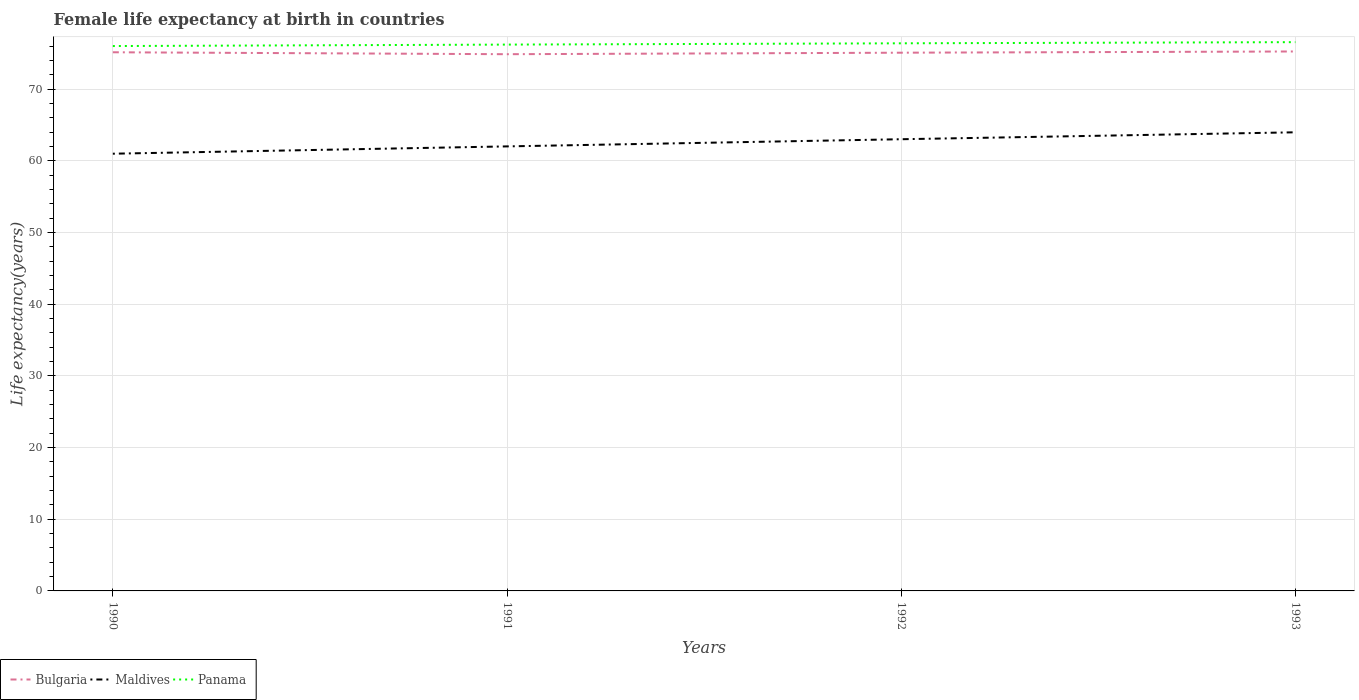Does the line corresponding to Bulgaria intersect with the line corresponding to Panama?
Offer a very short reply. No. Across all years, what is the maximum female life expectancy at birth in Maldives?
Keep it short and to the point. 61. What is the total female life expectancy at birth in Maldives in the graph?
Your answer should be very brief. -0.97. What is the difference between the highest and the second highest female life expectancy at birth in Panama?
Make the answer very short. 0.54. What is the difference between the highest and the lowest female life expectancy at birth in Maldives?
Your response must be concise. 2. How many years are there in the graph?
Give a very brief answer. 4. Are the values on the major ticks of Y-axis written in scientific E-notation?
Provide a short and direct response. No. Does the graph contain any zero values?
Your response must be concise. No. How are the legend labels stacked?
Your answer should be very brief. Horizontal. What is the title of the graph?
Offer a terse response. Female life expectancy at birth in countries. Does "Liberia" appear as one of the legend labels in the graph?
Ensure brevity in your answer.  No. What is the label or title of the Y-axis?
Your answer should be very brief. Life expectancy(years). What is the Life expectancy(years) of Bulgaria in 1990?
Your response must be concise. 75.15. What is the Life expectancy(years) of Maldives in 1990?
Keep it short and to the point. 61. What is the Life expectancy(years) in Panama in 1990?
Ensure brevity in your answer.  76.02. What is the Life expectancy(years) in Bulgaria in 1991?
Offer a terse response. 74.88. What is the Life expectancy(years) of Maldives in 1991?
Your answer should be compact. 62.02. What is the Life expectancy(years) in Panama in 1991?
Offer a very short reply. 76.22. What is the Life expectancy(years) of Bulgaria in 1992?
Offer a very short reply. 75.09. What is the Life expectancy(years) in Maldives in 1992?
Your response must be concise. 63.02. What is the Life expectancy(years) in Panama in 1992?
Ensure brevity in your answer.  76.4. What is the Life expectancy(years) of Bulgaria in 1993?
Provide a short and direct response. 75.26. What is the Life expectancy(years) of Maldives in 1993?
Ensure brevity in your answer.  63.98. What is the Life expectancy(years) of Panama in 1993?
Ensure brevity in your answer.  76.56. Across all years, what is the maximum Life expectancy(years) of Bulgaria?
Your answer should be very brief. 75.26. Across all years, what is the maximum Life expectancy(years) of Maldives?
Give a very brief answer. 63.98. Across all years, what is the maximum Life expectancy(years) in Panama?
Your answer should be very brief. 76.56. Across all years, what is the minimum Life expectancy(years) in Bulgaria?
Offer a terse response. 74.88. Across all years, what is the minimum Life expectancy(years) in Maldives?
Your response must be concise. 61. Across all years, what is the minimum Life expectancy(years) of Panama?
Your answer should be compact. 76.02. What is the total Life expectancy(years) in Bulgaria in the graph?
Your response must be concise. 300.38. What is the total Life expectancy(years) in Maldives in the graph?
Your response must be concise. 250.02. What is the total Life expectancy(years) of Panama in the graph?
Your answer should be compact. 305.2. What is the difference between the Life expectancy(years) of Bulgaria in 1990 and that in 1991?
Ensure brevity in your answer.  0.27. What is the difference between the Life expectancy(years) in Maldives in 1990 and that in 1991?
Your response must be concise. -1.02. What is the difference between the Life expectancy(years) in Panama in 1990 and that in 1991?
Your answer should be very brief. -0.2. What is the difference between the Life expectancy(years) of Bulgaria in 1990 and that in 1992?
Ensure brevity in your answer.  0.06. What is the difference between the Life expectancy(years) in Maldives in 1990 and that in 1992?
Provide a short and direct response. -2.02. What is the difference between the Life expectancy(years) in Panama in 1990 and that in 1992?
Offer a very short reply. -0.38. What is the difference between the Life expectancy(years) in Bulgaria in 1990 and that in 1993?
Your answer should be compact. -0.11. What is the difference between the Life expectancy(years) in Maldives in 1990 and that in 1993?
Ensure brevity in your answer.  -2.99. What is the difference between the Life expectancy(years) in Panama in 1990 and that in 1993?
Offer a very short reply. -0.54. What is the difference between the Life expectancy(years) of Bulgaria in 1991 and that in 1992?
Your answer should be very brief. -0.21. What is the difference between the Life expectancy(years) of Panama in 1991 and that in 1992?
Provide a short and direct response. -0.18. What is the difference between the Life expectancy(years) of Bulgaria in 1991 and that in 1993?
Give a very brief answer. -0.38. What is the difference between the Life expectancy(years) in Maldives in 1991 and that in 1993?
Offer a very short reply. -1.97. What is the difference between the Life expectancy(years) of Panama in 1991 and that in 1993?
Provide a short and direct response. -0.34. What is the difference between the Life expectancy(years) in Bulgaria in 1992 and that in 1993?
Ensure brevity in your answer.  -0.17. What is the difference between the Life expectancy(years) in Maldives in 1992 and that in 1993?
Your response must be concise. -0.97. What is the difference between the Life expectancy(years) in Panama in 1992 and that in 1993?
Make the answer very short. -0.16. What is the difference between the Life expectancy(years) of Bulgaria in 1990 and the Life expectancy(years) of Maldives in 1991?
Make the answer very short. 13.13. What is the difference between the Life expectancy(years) of Bulgaria in 1990 and the Life expectancy(years) of Panama in 1991?
Offer a terse response. -1.07. What is the difference between the Life expectancy(years) in Maldives in 1990 and the Life expectancy(years) in Panama in 1991?
Keep it short and to the point. -15.22. What is the difference between the Life expectancy(years) in Bulgaria in 1990 and the Life expectancy(years) in Maldives in 1992?
Provide a short and direct response. 12.13. What is the difference between the Life expectancy(years) in Bulgaria in 1990 and the Life expectancy(years) in Panama in 1992?
Ensure brevity in your answer.  -1.25. What is the difference between the Life expectancy(years) in Maldives in 1990 and the Life expectancy(years) in Panama in 1992?
Provide a succinct answer. -15.4. What is the difference between the Life expectancy(years) of Bulgaria in 1990 and the Life expectancy(years) of Maldives in 1993?
Ensure brevity in your answer.  11.17. What is the difference between the Life expectancy(years) of Bulgaria in 1990 and the Life expectancy(years) of Panama in 1993?
Your answer should be very brief. -1.41. What is the difference between the Life expectancy(years) of Maldives in 1990 and the Life expectancy(years) of Panama in 1993?
Offer a very short reply. -15.56. What is the difference between the Life expectancy(years) in Bulgaria in 1991 and the Life expectancy(years) in Maldives in 1992?
Ensure brevity in your answer.  11.86. What is the difference between the Life expectancy(years) of Bulgaria in 1991 and the Life expectancy(years) of Panama in 1992?
Make the answer very short. -1.52. What is the difference between the Life expectancy(years) of Maldives in 1991 and the Life expectancy(years) of Panama in 1992?
Offer a terse response. -14.38. What is the difference between the Life expectancy(years) in Bulgaria in 1991 and the Life expectancy(years) in Maldives in 1993?
Your answer should be compact. 10.9. What is the difference between the Life expectancy(years) in Bulgaria in 1991 and the Life expectancy(years) in Panama in 1993?
Your answer should be compact. -1.68. What is the difference between the Life expectancy(years) of Maldives in 1991 and the Life expectancy(years) of Panama in 1993?
Provide a short and direct response. -14.54. What is the difference between the Life expectancy(years) of Bulgaria in 1992 and the Life expectancy(years) of Maldives in 1993?
Keep it short and to the point. 11.11. What is the difference between the Life expectancy(years) in Bulgaria in 1992 and the Life expectancy(years) in Panama in 1993?
Offer a terse response. -1.47. What is the difference between the Life expectancy(years) of Maldives in 1992 and the Life expectancy(years) of Panama in 1993?
Provide a succinct answer. -13.54. What is the average Life expectancy(years) in Bulgaria per year?
Give a very brief answer. 75.09. What is the average Life expectancy(years) of Maldives per year?
Provide a succinct answer. 62.5. What is the average Life expectancy(years) of Panama per year?
Give a very brief answer. 76.3. In the year 1990, what is the difference between the Life expectancy(years) of Bulgaria and Life expectancy(years) of Maldives?
Your answer should be compact. 14.15. In the year 1990, what is the difference between the Life expectancy(years) in Bulgaria and Life expectancy(years) in Panama?
Keep it short and to the point. -0.87. In the year 1990, what is the difference between the Life expectancy(years) of Maldives and Life expectancy(years) of Panama?
Provide a succinct answer. -15.02. In the year 1991, what is the difference between the Life expectancy(years) of Bulgaria and Life expectancy(years) of Maldives?
Your answer should be compact. 12.86. In the year 1991, what is the difference between the Life expectancy(years) of Bulgaria and Life expectancy(years) of Panama?
Your answer should be very brief. -1.34. In the year 1991, what is the difference between the Life expectancy(years) of Maldives and Life expectancy(years) of Panama?
Provide a succinct answer. -14.2. In the year 1992, what is the difference between the Life expectancy(years) in Bulgaria and Life expectancy(years) in Maldives?
Make the answer very short. 12.07. In the year 1992, what is the difference between the Life expectancy(years) in Bulgaria and Life expectancy(years) in Panama?
Provide a short and direct response. -1.31. In the year 1992, what is the difference between the Life expectancy(years) of Maldives and Life expectancy(years) of Panama?
Make the answer very short. -13.38. In the year 1993, what is the difference between the Life expectancy(years) in Bulgaria and Life expectancy(years) in Maldives?
Keep it short and to the point. 11.28. In the year 1993, what is the difference between the Life expectancy(years) in Bulgaria and Life expectancy(years) in Panama?
Give a very brief answer. -1.3. In the year 1993, what is the difference between the Life expectancy(years) of Maldives and Life expectancy(years) of Panama?
Your response must be concise. -12.58. What is the ratio of the Life expectancy(years) of Maldives in 1990 to that in 1991?
Keep it short and to the point. 0.98. What is the ratio of the Life expectancy(years) in Panama in 1990 to that in 1991?
Make the answer very short. 1. What is the ratio of the Life expectancy(years) in Bulgaria in 1990 to that in 1992?
Give a very brief answer. 1. What is the ratio of the Life expectancy(years) in Maldives in 1990 to that in 1992?
Give a very brief answer. 0.97. What is the ratio of the Life expectancy(years) of Bulgaria in 1990 to that in 1993?
Offer a very short reply. 1. What is the ratio of the Life expectancy(years) of Maldives in 1990 to that in 1993?
Ensure brevity in your answer.  0.95. What is the ratio of the Life expectancy(years) in Bulgaria in 1991 to that in 1992?
Give a very brief answer. 1. What is the ratio of the Life expectancy(years) of Maldives in 1991 to that in 1992?
Offer a terse response. 0.98. What is the ratio of the Life expectancy(years) in Panama in 1991 to that in 1992?
Provide a short and direct response. 1. What is the ratio of the Life expectancy(years) of Maldives in 1991 to that in 1993?
Your response must be concise. 0.97. What is the ratio of the Life expectancy(years) in Bulgaria in 1992 to that in 1993?
Provide a succinct answer. 1. What is the ratio of the Life expectancy(years) in Maldives in 1992 to that in 1993?
Ensure brevity in your answer.  0.98. What is the ratio of the Life expectancy(years) of Panama in 1992 to that in 1993?
Keep it short and to the point. 1. What is the difference between the highest and the second highest Life expectancy(years) of Bulgaria?
Offer a very short reply. 0.11. What is the difference between the highest and the second highest Life expectancy(years) of Panama?
Ensure brevity in your answer.  0.16. What is the difference between the highest and the lowest Life expectancy(years) in Bulgaria?
Make the answer very short. 0.38. What is the difference between the highest and the lowest Life expectancy(years) in Maldives?
Offer a terse response. 2.99. What is the difference between the highest and the lowest Life expectancy(years) of Panama?
Provide a short and direct response. 0.54. 